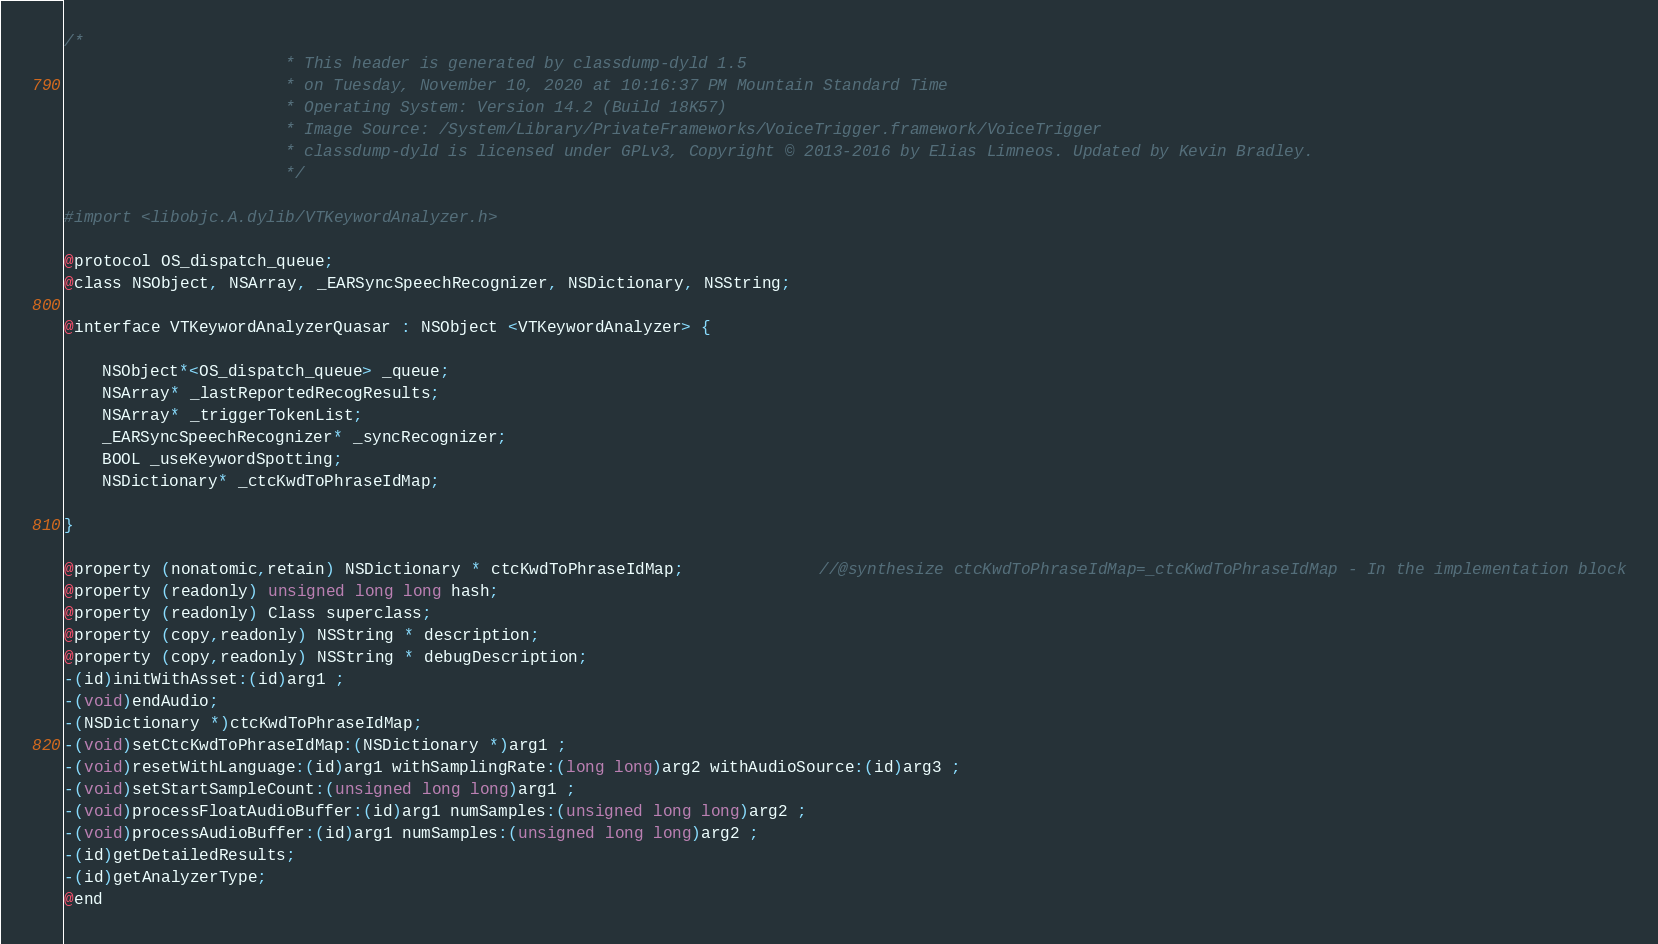Convert code to text. <code><loc_0><loc_0><loc_500><loc_500><_C_>/*
                       * This header is generated by classdump-dyld 1.5
                       * on Tuesday, November 10, 2020 at 10:16:37 PM Mountain Standard Time
                       * Operating System: Version 14.2 (Build 18K57)
                       * Image Source: /System/Library/PrivateFrameworks/VoiceTrigger.framework/VoiceTrigger
                       * classdump-dyld is licensed under GPLv3, Copyright © 2013-2016 by Elias Limneos. Updated by Kevin Bradley.
                       */

#import <libobjc.A.dylib/VTKeywordAnalyzer.h>

@protocol OS_dispatch_queue;
@class NSObject, NSArray, _EARSyncSpeechRecognizer, NSDictionary, NSString;

@interface VTKeywordAnalyzerQuasar : NSObject <VTKeywordAnalyzer> {

	NSObject*<OS_dispatch_queue> _queue;
	NSArray* _lastReportedRecogResults;
	NSArray* _triggerTokenList;
	_EARSyncSpeechRecognizer* _syncRecognizer;
	BOOL _useKeywordSpotting;
	NSDictionary* _ctcKwdToPhraseIdMap;

}

@property (nonatomic,retain) NSDictionary * ctcKwdToPhraseIdMap;              //@synthesize ctcKwdToPhraseIdMap=_ctcKwdToPhraseIdMap - In the implementation block
@property (readonly) unsigned long long hash; 
@property (readonly) Class superclass; 
@property (copy,readonly) NSString * description; 
@property (copy,readonly) NSString * debugDescription; 
-(id)initWithAsset:(id)arg1 ;
-(void)endAudio;
-(NSDictionary *)ctcKwdToPhraseIdMap;
-(void)setCtcKwdToPhraseIdMap:(NSDictionary *)arg1 ;
-(void)resetWithLanguage:(id)arg1 withSamplingRate:(long long)arg2 withAudioSource:(id)arg3 ;
-(void)setStartSampleCount:(unsigned long long)arg1 ;
-(void)processFloatAudioBuffer:(id)arg1 numSamples:(unsigned long long)arg2 ;
-(void)processAudioBuffer:(id)arg1 numSamples:(unsigned long long)arg2 ;
-(id)getDetailedResults;
-(id)getAnalyzerType;
@end

</code> 